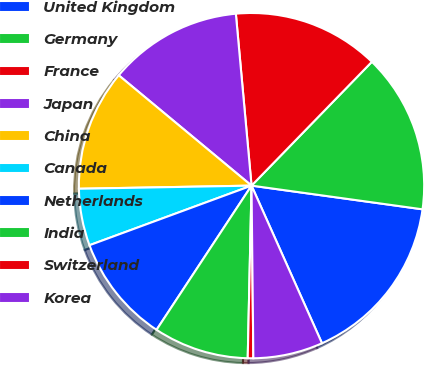Convert chart to OTSL. <chart><loc_0><loc_0><loc_500><loc_500><pie_chart><fcel>United Kingdom<fcel>Germany<fcel>France<fcel>Japan<fcel>China<fcel>Canada<fcel>Netherlands<fcel>India<fcel>Switzerland<fcel>Korea<nl><fcel>16.12%<fcel>14.92%<fcel>13.72%<fcel>12.52%<fcel>11.32%<fcel>5.32%<fcel>10.12%<fcel>8.92%<fcel>0.52%<fcel>6.52%<nl></chart> 